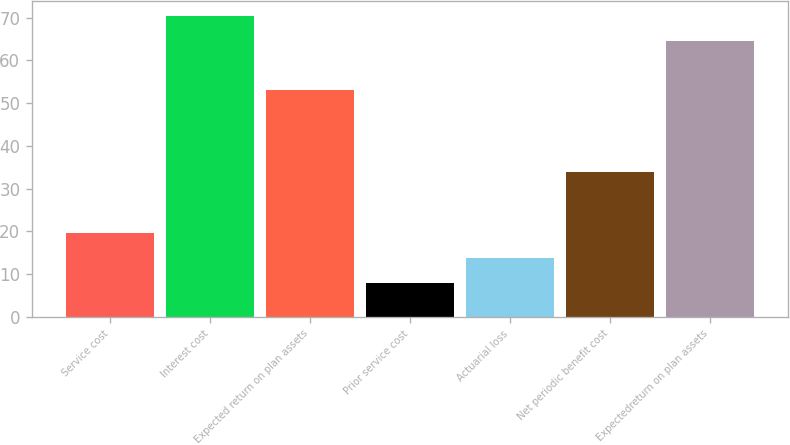Convert chart to OTSL. <chart><loc_0><loc_0><loc_500><loc_500><bar_chart><fcel>Service cost<fcel>Interest cost<fcel>Expected return on plan assets<fcel>Prior service cost<fcel>Actuarial loss<fcel>Net periodic benefit cost<fcel>Expectedreturn on plan assets<nl><fcel>19.6<fcel>70.4<fcel>53<fcel>8<fcel>13.8<fcel>34<fcel>64.6<nl></chart> 